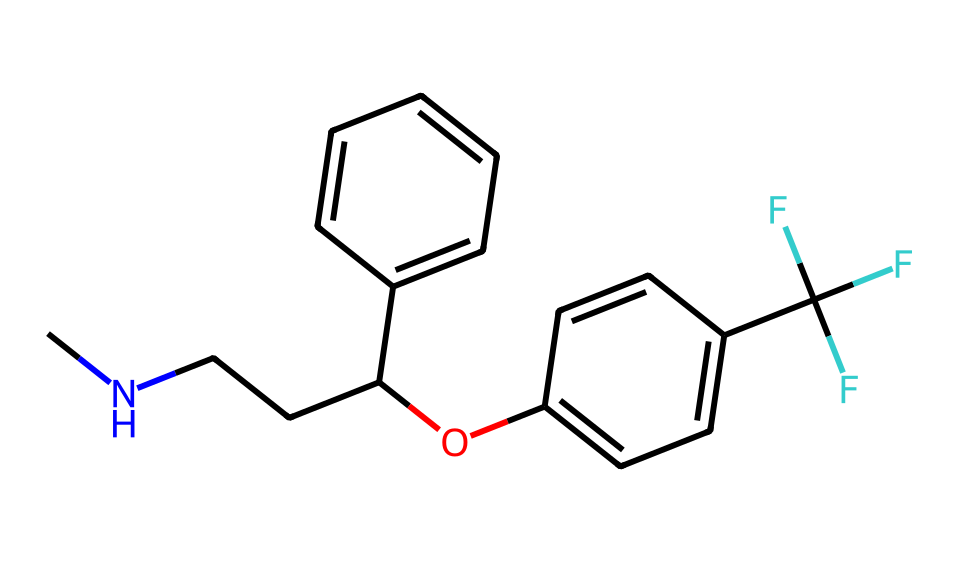What is the main functional group in fluoxetine? The SMILES representation shows a hydroxyl group (–OH) represented by the substructure "Oc1" where "O" is the oxygen atom connected to a carbon atom of an aromatic ring. This indicates the presence of a hydroxyl functional group, which is characteristic of alcohols.
Answer: hydroxyl How many carbon atoms are present in this compound? By examining the SMILES structure, we can count the carbon atoms represented. The line structure allows for an easy counting of 'C' characters. It shows that there are 17 carbon atoms in total.
Answer: 17 What type of medicinal compound is fluoxetine classified as? Fluoxetine is an antidepressant and is classified as a selective serotonin reuptake inhibitor (SSRI). This classification is due to its mechanism of action affecting serotonin levels in the brain.
Answer: SSRI Are there any nitrogen atoms in the structure of fluoxetine? The SMILES representation has a 'N' symbol present in the molecule which indicates the presence of nitrogen atoms. By counting, we see that there is 1 nitrogen atom in this compound.
Answer: 1 What effect does the trifluoromethyl group have on fluoxetine? The trifluoromethyl group, denoted by "C(F)(F)F", is known to increase lipophilicity and may also enhance the potency of the drug by influencing the molecular interaction with its target receptors.
Answer: increases potency Which element is responsible for the presence of the aromatic character in fluoxetine? The presence of "c" in the SMILES notation indicates aromatic carbon atoms, which are part of the benzene rings in the structure. This delineates that these resist conjugation and provide the compound with its aromatic properties.
Answer: carbon 